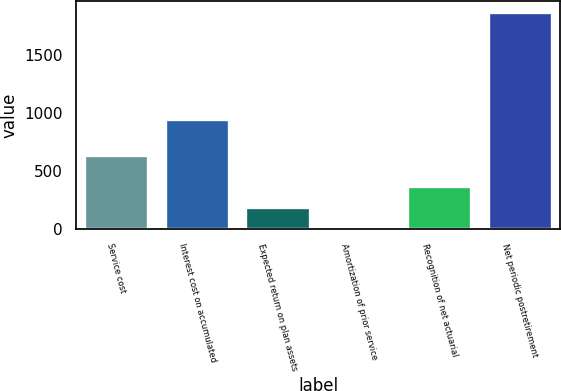<chart> <loc_0><loc_0><loc_500><loc_500><bar_chart><fcel>Service cost<fcel>Interest cost on accumulated<fcel>Expected return on plan assets<fcel>Amortization of prior service<fcel>Recognition of net actuarial<fcel>Net periodic postretirement<nl><fcel>641<fcel>947<fcel>189.06<fcel>2.18<fcel>375.94<fcel>1871<nl></chart> 